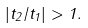Convert formula to latex. <formula><loc_0><loc_0><loc_500><loc_500>| t _ { 2 } / t _ { 1 } | > 1 .</formula> 